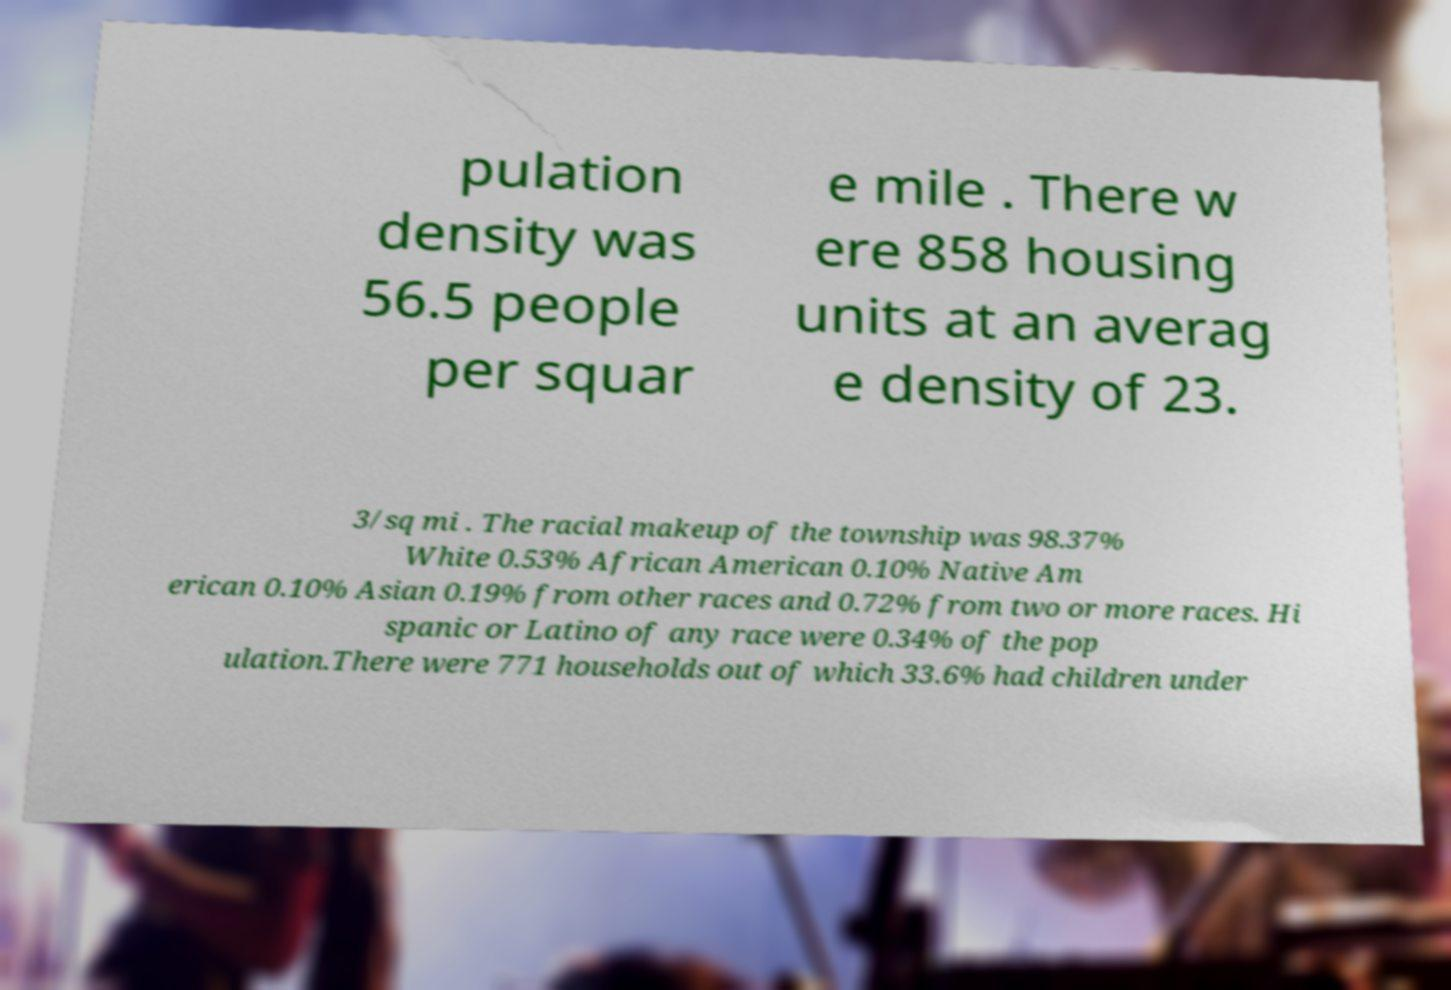Could you extract and type out the text from this image? pulation density was 56.5 people per squar e mile . There w ere 858 housing units at an averag e density of 23. 3/sq mi . The racial makeup of the township was 98.37% White 0.53% African American 0.10% Native Am erican 0.10% Asian 0.19% from other races and 0.72% from two or more races. Hi spanic or Latino of any race were 0.34% of the pop ulation.There were 771 households out of which 33.6% had children under 